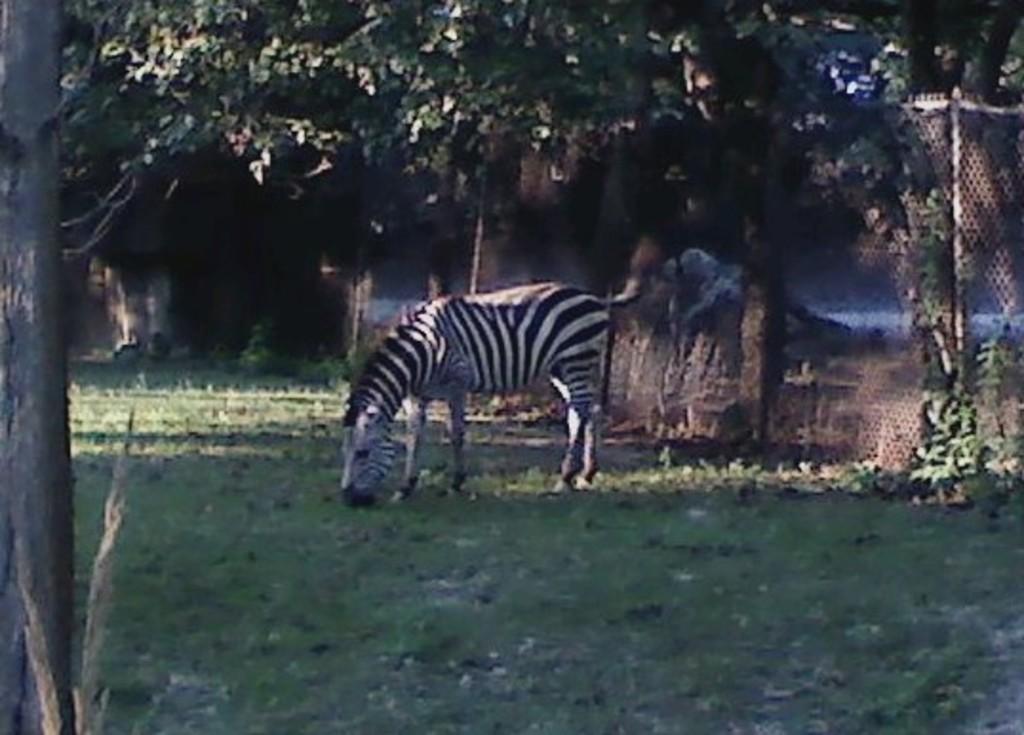Please provide a concise description of this image. As we can see in the image there is grass, zebra, trees, wall and fence. 